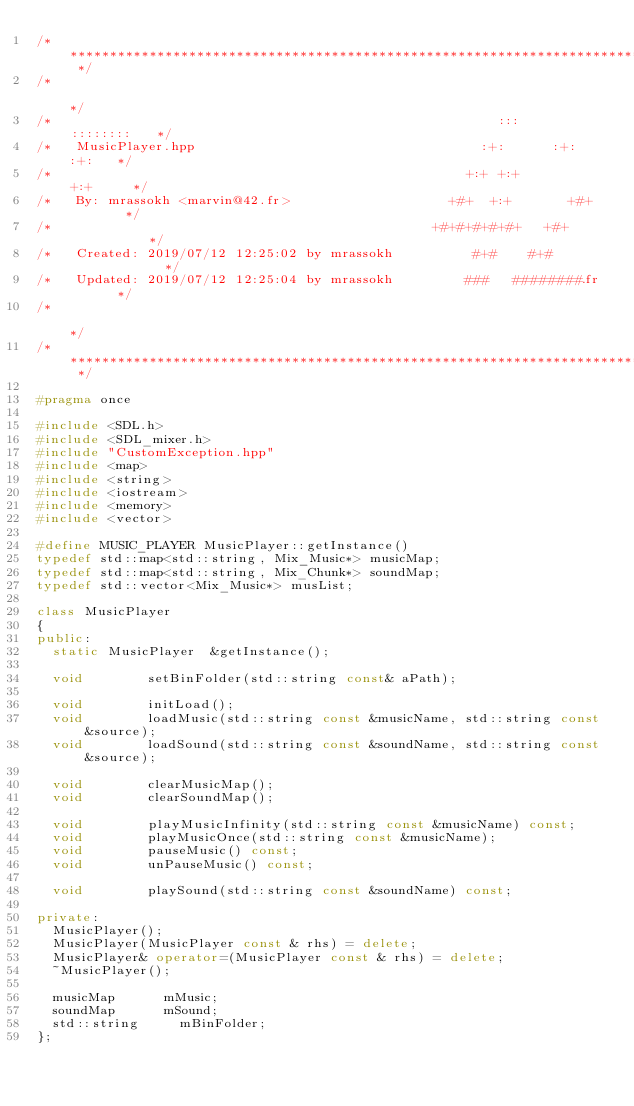Convert code to text. <code><loc_0><loc_0><loc_500><loc_500><_C++_>/* ************************************************************************** */
/*                                                                            */
/*                                                        :::      ::::::::   */
/*   MusicPlayer.hpp                                    :+:      :+:    :+:   */
/*                                                    +:+ +:+         +:+     */
/*   By: mrassokh <marvin@42.fr>                    +#+  +:+       +#+        */
/*                                                +#+#+#+#+#+   +#+           */
/*   Created: 2019/07/12 12:25:02 by mrassokh          #+#    #+#             */
/*   Updated: 2019/07/12 12:25:04 by mrassokh         ###   ########.fr       */
/*                                                                            */
/* ************************************************************************** */

#pragma once

#include <SDL.h>
#include <SDL_mixer.h>
#include "CustomException.hpp"
#include <map>
#include <string>
#include <iostream>
#include <memory>
#include <vector>

#define MUSIC_PLAYER MusicPlayer::getInstance()
typedef std::map<std::string, Mix_Music*> musicMap;
typedef std::map<std::string, Mix_Chunk*> soundMap;
typedef std::vector<Mix_Music*> musList;

class MusicPlayer
{
public:
	static MusicPlayer 	&getInstance();

	void 				setBinFolder(std::string const& aPath);

	void 				initLoad();
	void 				loadMusic(std::string const &musicName, std::string const &source);
	void 				loadSound(std::string const &soundName, std::string const &source);

	void 				clearMusicMap();
	void 				clearSoundMap();

	void 				playMusicInfinity(std::string const &musicName) const;
	void 				playMusicOnce(std::string const &musicName);
	void 				pauseMusic() const;
	void 				unPauseMusic() const;

	void 				playSound(std::string const &soundName) const;

private:
	MusicPlayer();
	MusicPlayer(MusicPlayer const & rhs) = delete;
	MusicPlayer& operator=(MusicPlayer const & rhs) = delete;
	~MusicPlayer();

	musicMap 			mMusic;
	soundMap 			mSound;
	std::string			mBinFolder;
};
</code> 